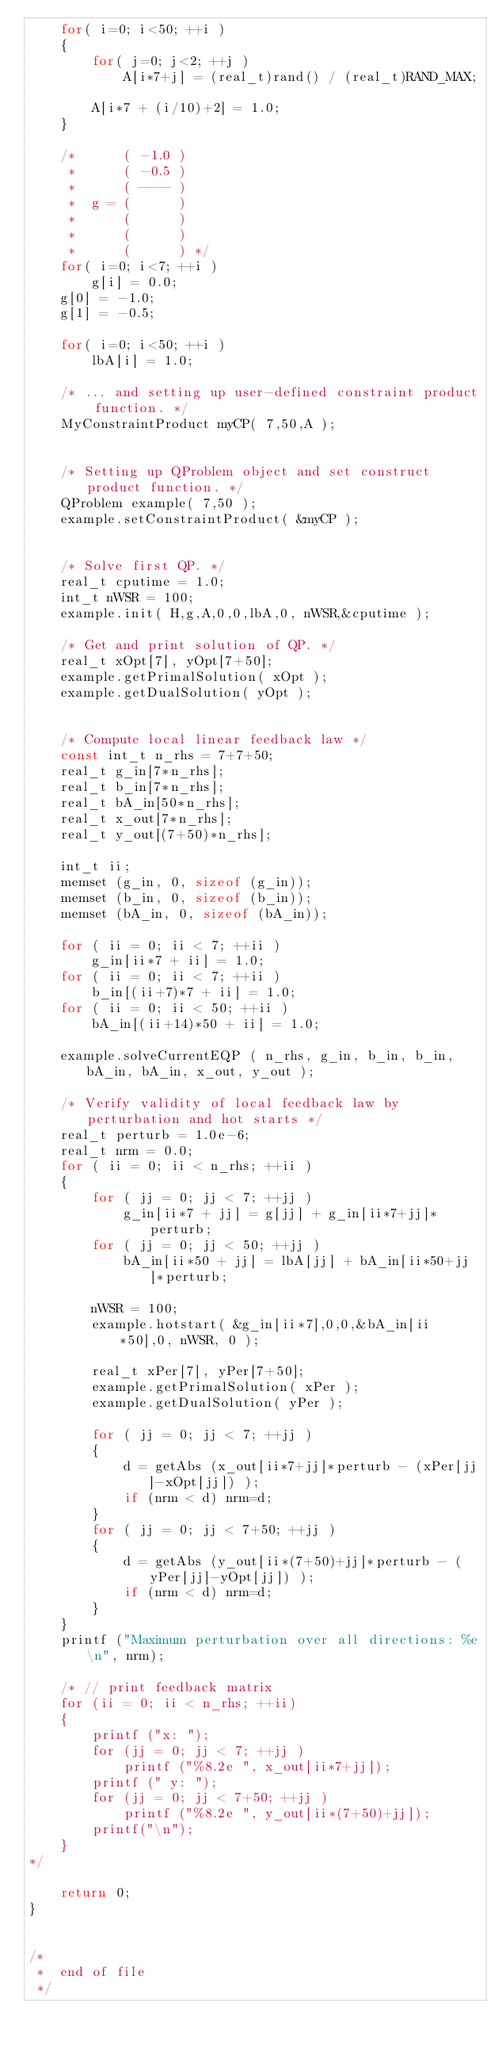<code> <loc_0><loc_0><loc_500><loc_500><_C++_>	for( i=0; i<50; ++i )
	{
		for( j=0; j<2; ++j )
			A[i*7+j] = (real_t)rand() / (real_t)RAND_MAX;

		A[i*7 + (i/10)+2] = 1.0;
	}

	/*	    ( -1.0 )
	 *	    ( -0.5 )
	 *	    ( ---- )
	 *	g = (      )
	 *	    (      )
	 *	    (      )
	 *	    (      ) */
	for( i=0; i<7; ++i )
		g[i] = 0.0;
	g[0] = -1.0;
	g[1] = -0.5;

	for( i=0; i<50; ++i )
		lbA[i] = 1.0;

	/* ... and setting up user-defined constraint product function. */
	MyConstraintProduct myCP( 7,50,A );


	/* Setting up QProblem object and set construct product function. */
	QProblem example( 7,50 );
	example.setConstraintProduct( &myCP );


	/* Solve first QP. */
	real_t cputime = 1.0;
	int_t nWSR = 100;
	example.init( H,g,A,0,0,lbA,0, nWSR,&cputime );

	/* Get and print solution of QP. */
	real_t xOpt[7], yOpt[7+50];
	example.getPrimalSolution( xOpt );
	example.getDualSolution( yOpt );


	/* Compute local linear feedback law */
	const int_t n_rhs = 7+7+50;
	real_t g_in[7*n_rhs];
	real_t b_in[7*n_rhs];
	real_t bA_in[50*n_rhs];
	real_t x_out[7*n_rhs];
	real_t y_out[(7+50)*n_rhs];

	int_t ii;
	memset (g_in, 0, sizeof (g_in));
	memset (b_in, 0, sizeof (b_in));
	memset (bA_in, 0, sizeof (bA_in));

	for ( ii = 0; ii < 7; ++ii )
		g_in[ii*7 + ii] = 1.0;
	for ( ii = 0; ii < 7; ++ii )
		b_in[(ii+7)*7 + ii] = 1.0;
	for ( ii = 0; ii < 50; ++ii )
		bA_in[(ii+14)*50 + ii] = 1.0;

	example.solveCurrentEQP ( n_rhs, g_in, b_in, b_in, bA_in, bA_in, x_out, y_out );

	/* Verify validity of local feedback law by perturbation and hot starts */
	real_t perturb = 1.0e-6;
	real_t nrm = 0.0;
	for ( ii = 0; ii < n_rhs; ++ii )
	{
		for ( jj = 0; jj < 7; ++jj )
			g_in[ii*7 + jj] = g[jj] + g_in[ii*7+jj]*perturb;
		for ( jj = 0; jj < 50; ++jj )
			bA_in[ii*50 + jj] = lbA[jj] + bA_in[ii*50+jj]*perturb;

		nWSR = 100;
		example.hotstart( &g_in[ii*7],0,0,&bA_in[ii*50],0, nWSR, 0 );

		real_t xPer[7], yPer[7+50];
		example.getPrimalSolution( xPer );
		example.getDualSolution( yPer );

		for ( jj = 0; jj < 7; ++jj )
		{
			d = getAbs (x_out[ii*7+jj]*perturb - (xPer[jj]-xOpt[jj]) );
			if (nrm < d) nrm=d;
		}
		for ( jj = 0; jj < 7+50; ++jj )
		{
			d = getAbs (y_out[ii*(7+50)+jj]*perturb - (yPer[jj]-yOpt[jj]) );
			if (nrm < d) nrm=d;
		}
	}
	printf ("Maximum perturbation over all directions: %e\n", nrm);

	/* // print feedback matrix
	for (ii = 0; ii < n_rhs; ++ii)
	{
		printf ("x: ");
		for (jj = 0; jj < 7; ++jj )
			printf ("%8.2e ", x_out[ii*7+jj]);
		printf (" y: ");
		for (jj = 0; jj < 7+50; ++jj )
			printf ("%8.2e ", y_out[ii*(7+50)+jj]);
		printf("\n");
	}
*/

	return 0;
}


/*
 *	end of file
 */
</code> 